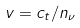<formula> <loc_0><loc_0><loc_500><loc_500>v = c _ { t } / n _ { \nu }</formula> 